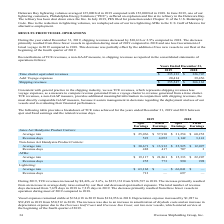According to Overseas Shipholding Group's financial document, How much did TCE revenues increased during 2019 from 2018? According to the financial document, $8,426. The relevant text states: "During 2019, TCE revenues increased by $8,426, or 2.6%, to $335,133 from $326,707 in 2018. The increase primarily resulted from an increase in av..." Also, What led to the increase in TCE revenues? an increase in average daily rates earned by our fleet and decreased spot market exposure.. The document states: ",707 in 2018. The increase primarily resulted from an increase in average daily rates earned by our fleet and decreased spot market exposure. The tota..." Also, What is the vessel expenses in 2019 and 2018 respectively? The document shows two values: $134,618 and $134,956. From the document: "Vessel expenses remained stable at $134,618 in 2019 from $134,956 in 2018. Depreciation expense increased by $1,987 to $52,499 in 2019 from $50, expen..." Also, can you calculate: What is the change in Jones Act Handysize Product Carriers: Average rate in Spot Earnings between 2018 and 2019? Based on the calculation: 25,036-31,254, the result is -6218. This is based on the information: "Average rate $ 25,036 $ 57,910 $ 31,254 $ 60,252 Average rate $ 25,036 $ 57,910 $ 31,254 $ 60,252..." The key data points involved are: 25,036, 31,254. Also, can you calculate: What is the change in Jones Act Handysize Product Carriers: Revenue days in Spot Earnings between 2018 and 2019? Based on the calculation: 523-1,142, the result is -619. This is based on the information: "Revenue days 523 4,052 1,142 3,141 Revenue days 523 4,052 1,142 3,141..." The key data points involved are: 1,142, 523. Also, can you calculate: What is the change in Non-Jones Act Handysize Product Carriers: Average rate in Spot Earnings between 2018 and 2019? Based on the calculation: 30,671-25,925, the result is 4746. This is based on the information: "Average rate $ 30,671 $ 13,912 $ 25,925 $ 12,097 Average rate $ 30,671 $ 13,912 $ 25,925 $ 12,097..." The key data points involved are: 25,925, 30,671. 